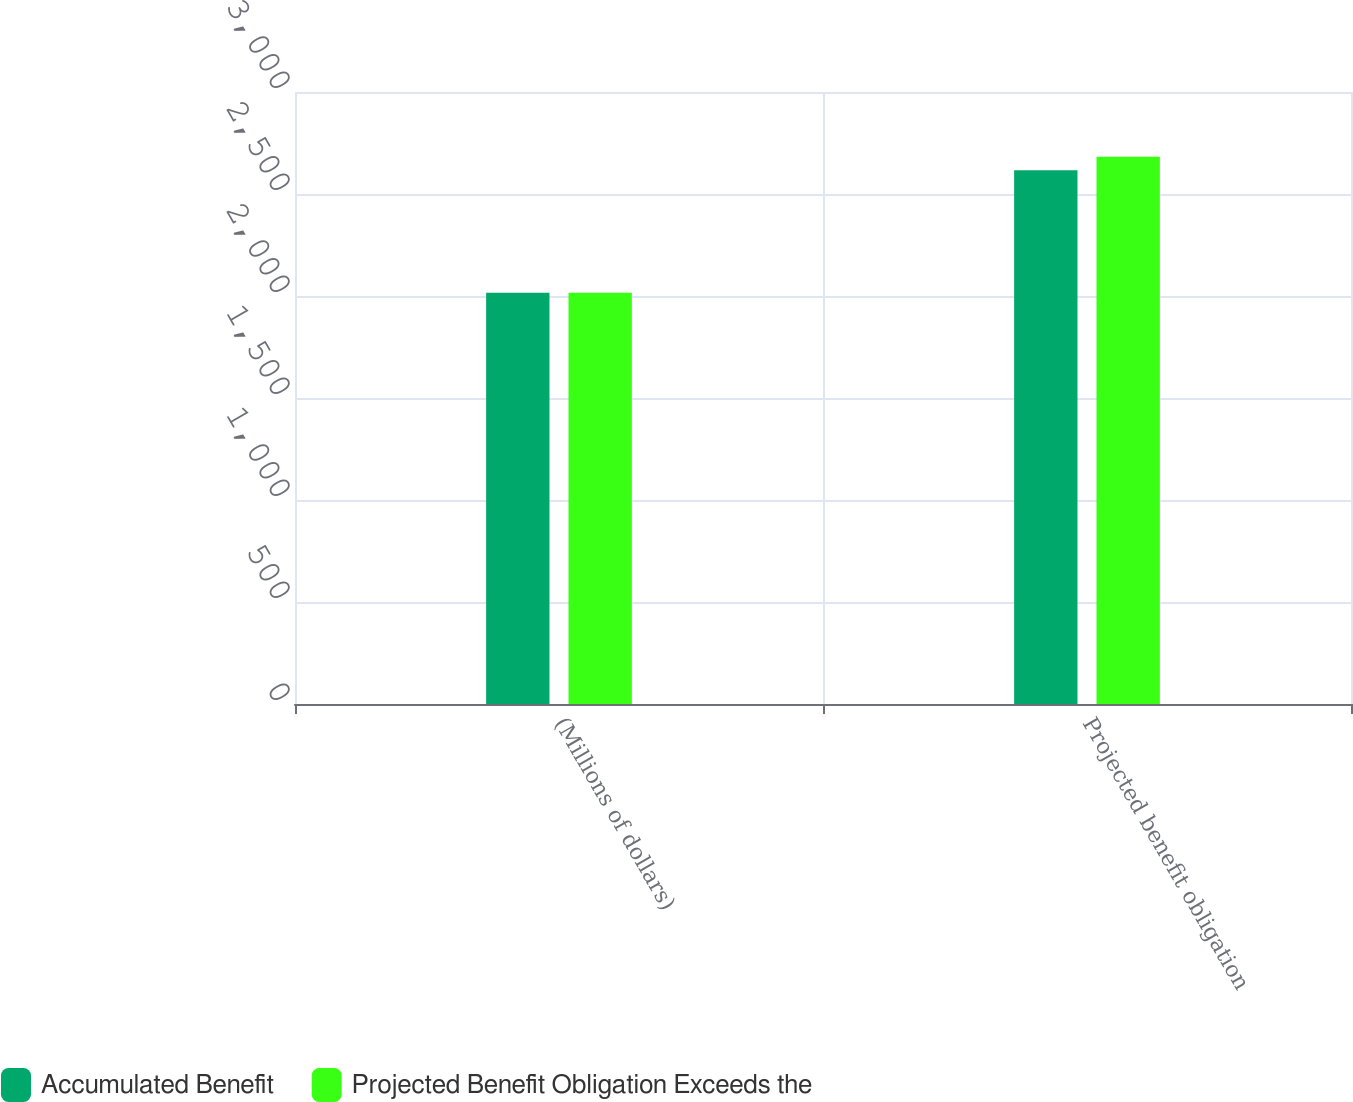Convert chart. <chart><loc_0><loc_0><loc_500><loc_500><stacked_bar_chart><ecel><fcel>(Millions of dollars)<fcel>Projected benefit obligation<nl><fcel>Accumulated Benefit<fcel>2016<fcel>2616<nl><fcel>Projected Benefit Obligation Exceeds the<fcel>2016<fcel>2682<nl></chart> 